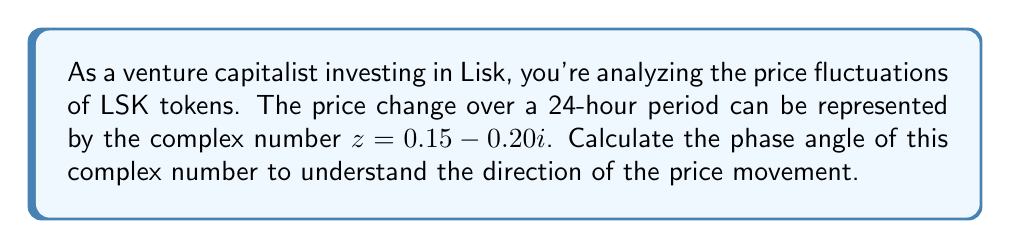Give your solution to this math problem. To calculate the phase angle of a complex number $z = a + bi$, we use the arctangent function:

$\theta = \tan^{-1}(\frac{b}{a})$

Where:
$a$ is the real part
$b$ is the imaginary part

For $z = 0.15 - 0.20i$:
$a = 0.15$
$b = -0.20$

Step 1: Calculate the ratio of $b$ to $a$:
$\frac{b}{a} = \frac{-0.20}{0.15} = -1.3333$

Step 2: Apply the arctangent function:
$\theta = \tan^{-1}(-1.3333)$

Step 3: Calculate the result:
$\theta \approx -0.9273$ radians

Step 4: Convert to degrees:
$\theta \approx -0.9273 \times \frac{180}{\pi} \approx -53.13°$

Step 5: Adjust the angle to be in the correct quadrant:
Since $a$ is positive and $b$ is negative, the angle is in the fourth quadrant.
The correct phase angle is:
$\theta = 360° - 53.13° = 306.87°$

This angle represents the direction of the price movement in the complex plane, with 0° corresponding to a purely positive real movement (price increase) and angles increasing counterclockwise.
Answer: $306.87°$ 